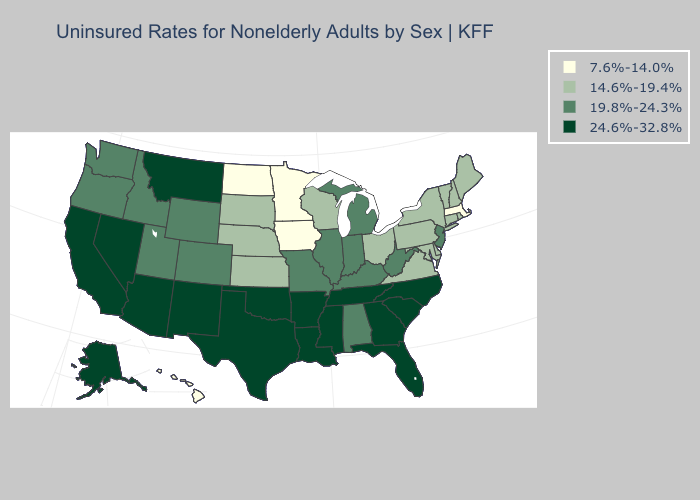Name the states that have a value in the range 14.6%-19.4%?
Concise answer only. Connecticut, Delaware, Kansas, Maine, Maryland, Nebraska, New Hampshire, New York, Ohio, Pennsylvania, Rhode Island, South Dakota, Vermont, Virginia, Wisconsin. Which states have the highest value in the USA?
Write a very short answer. Alaska, Arizona, Arkansas, California, Florida, Georgia, Louisiana, Mississippi, Montana, Nevada, New Mexico, North Carolina, Oklahoma, South Carolina, Tennessee, Texas. Among the states that border South Dakota , does Minnesota have the highest value?
Keep it brief. No. What is the lowest value in the MidWest?
Answer briefly. 7.6%-14.0%. Does the map have missing data?
Be succinct. No. Among the states that border California , which have the highest value?
Write a very short answer. Arizona, Nevada. Which states have the lowest value in the West?
Short answer required. Hawaii. Does North Dakota have the lowest value in the MidWest?
Quick response, please. Yes. Name the states that have a value in the range 14.6%-19.4%?
Concise answer only. Connecticut, Delaware, Kansas, Maine, Maryland, Nebraska, New Hampshire, New York, Ohio, Pennsylvania, Rhode Island, South Dakota, Vermont, Virginia, Wisconsin. Name the states that have a value in the range 24.6%-32.8%?
Keep it brief. Alaska, Arizona, Arkansas, California, Florida, Georgia, Louisiana, Mississippi, Montana, Nevada, New Mexico, North Carolina, Oklahoma, South Carolina, Tennessee, Texas. What is the highest value in the USA?
Short answer required. 24.6%-32.8%. Name the states that have a value in the range 14.6%-19.4%?
Concise answer only. Connecticut, Delaware, Kansas, Maine, Maryland, Nebraska, New Hampshire, New York, Ohio, Pennsylvania, Rhode Island, South Dakota, Vermont, Virginia, Wisconsin. Which states have the lowest value in the USA?
Give a very brief answer. Hawaii, Iowa, Massachusetts, Minnesota, North Dakota. Does Kentucky have the highest value in the USA?
Concise answer only. No. 